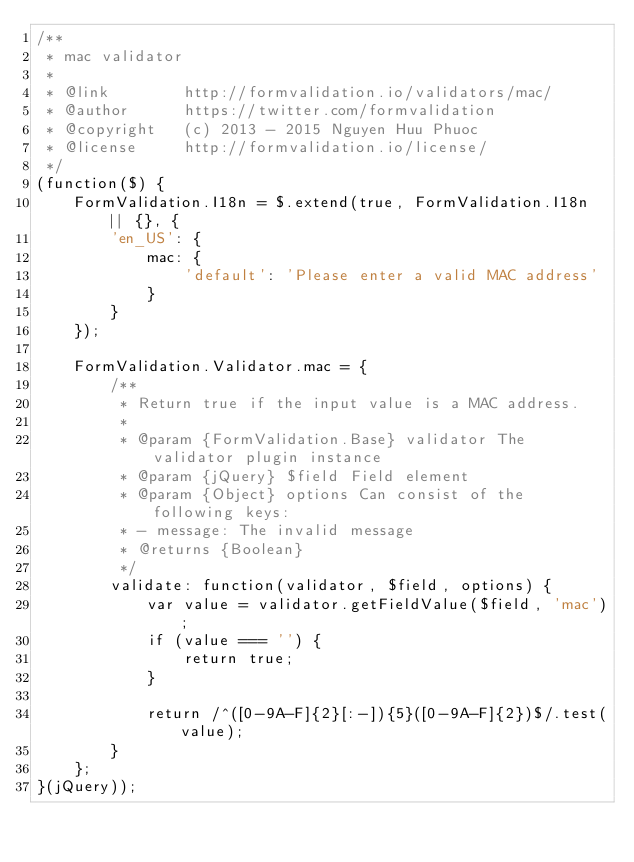<code> <loc_0><loc_0><loc_500><loc_500><_JavaScript_>/**
 * mac validator
 *
 * @link        http://formvalidation.io/validators/mac/
 * @author      https://twitter.com/formvalidation
 * @copyright   (c) 2013 - 2015 Nguyen Huu Phuoc
 * @license     http://formvalidation.io/license/
 */
(function($) {
    FormValidation.I18n = $.extend(true, FormValidation.I18n || {}, {
        'en_US': {
            mac: {
                'default': 'Please enter a valid MAC address'
            }
        }
    });

    FormValidation.Validator.mac = {
        /**
         * Return true if the input value is a MAC address.
         *
         * @param {FormValidation.Base} validator The validator plugin instance
         * @param {jQuery} $field Field element
         * @param {Object} options Can consist of the following keys:
         * - message: The invalid message
         * @returns {Boolean}
         */
        validate: function(validator, $field, options) {
            var value = validator.getFieldValue($field, 'mac');
            if (value === '') {
                return true;
            }

            return /^([0-9A-F]{2}[:-]){5}([0-9A-F]{2})$/.test(value);
        }
    };
}(jQuery));
</code> 